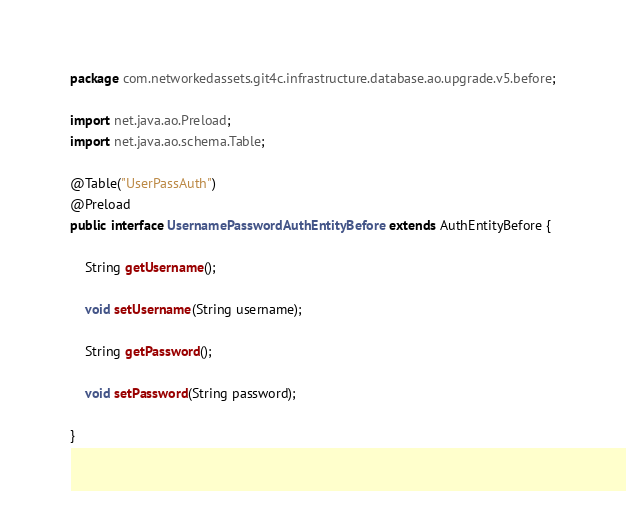<code> <loc_0><loc_0><loc_500><loc_500><_Java_>package com.networkedassets.git4c.infrastructure.database.ao.upgrade.v5.before;

import net.java.ao.Preload;
import net.java.ao.schema.Table;

@Table("UserPassAuth")
@Preload
public interface UsernamePasswordAuthEntityBefore extends AuthEntityBefore {

    String getUsername();

    void setUsername(String username);

    String getPassword();

    void setPassword(String password);

}
</code> 